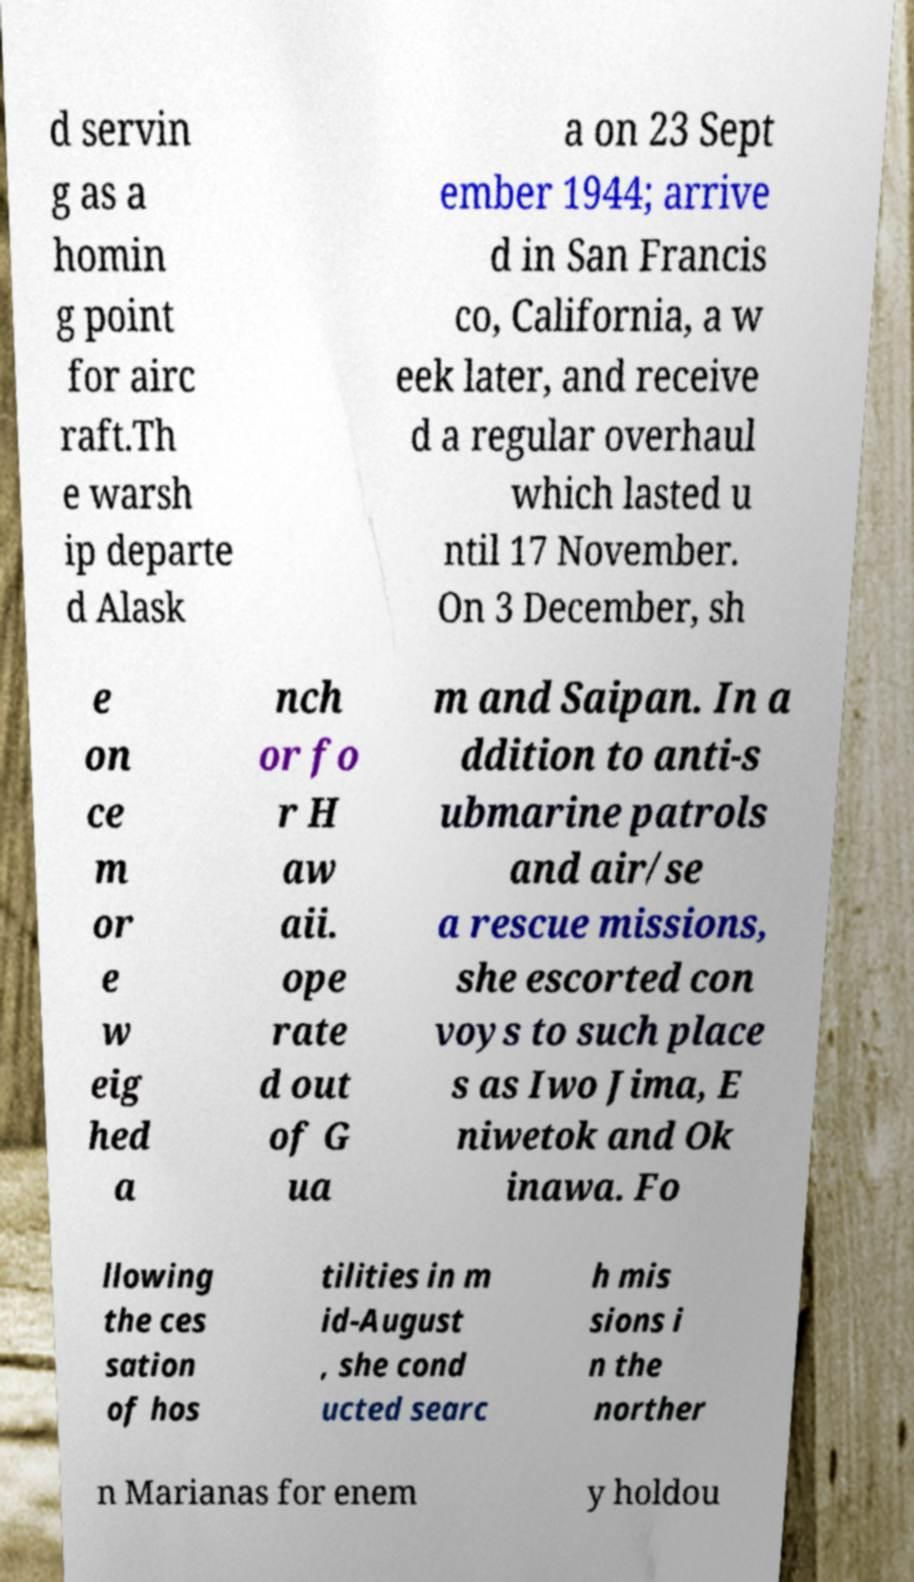Please read and relay the text visible in this image. What does it say? d servin g as a homin g point for airc raft.Th e warsh ip departe d Alask a on 23 Sept ember 1944; arrive d in San Francis co, California, a w eek later, and receive d a regular overhaul which lasted u ntil 17 November. On 3 December, sh e on ce m or e w eig hed a nch or fo r H aw aii. ope rate d out of G ua m and Saipan. In a ddition to anti-s ubmarine patrols and air/se a rescue missions, she escorted con voys to such place s as Iwo Jima, E niwetok and Ok inawa. Fo llowing the ces sation of hos tilities in m id-August , she cond ucted searc h mis sions i n the norther n Marianas for enem y holdou 